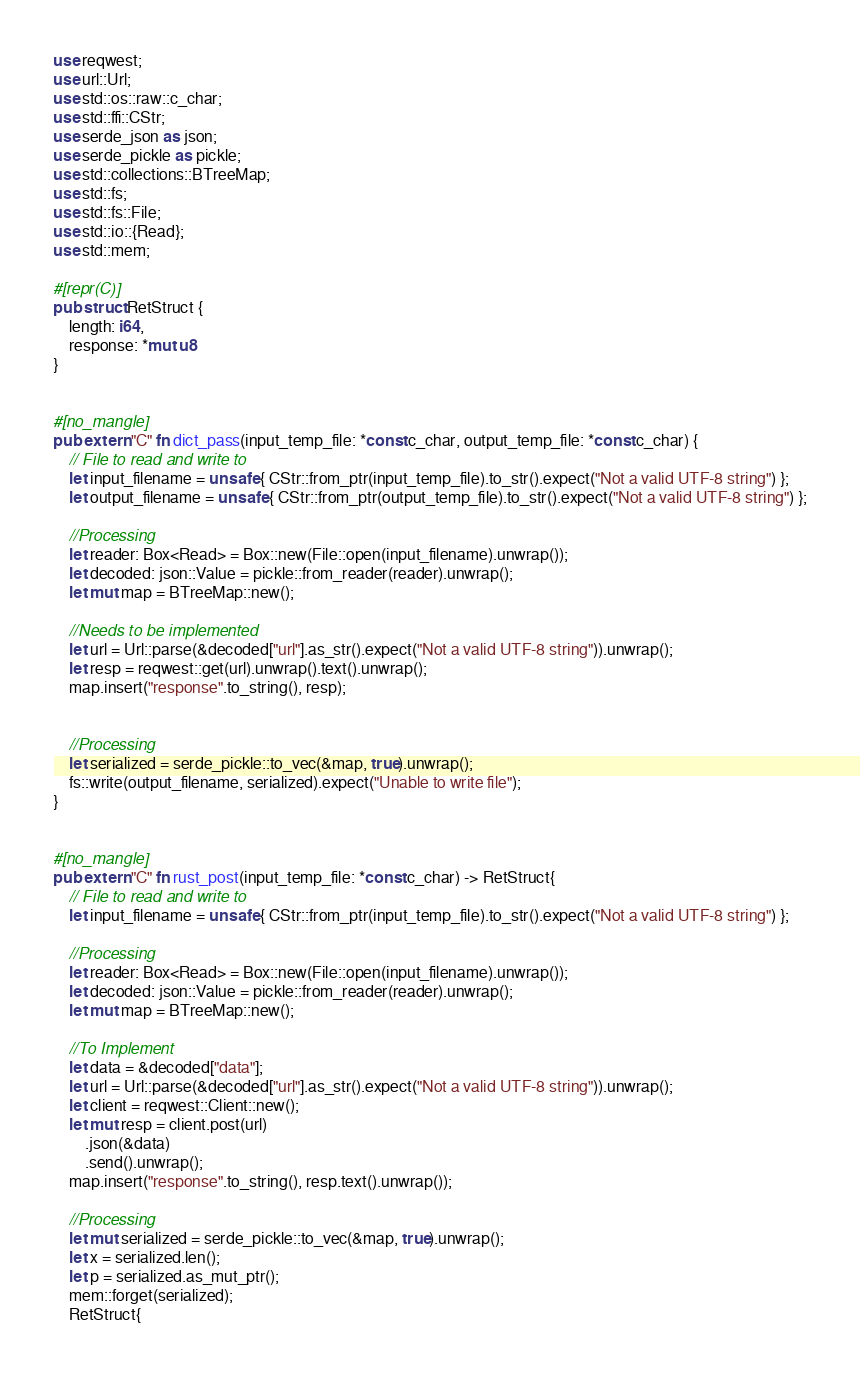Convert code to text. <code><loc_0><loc_0><loc_500><loc_500><_Rust_>use reqwest;
use url::Url;
use std::os::raw::c_char;
use std::ffi::CStr;
use serde_json as json;
use serde_pickle as pickle;
use std::collections::BTreeMap;
use std::fs;
use std::fs::File;
use std::io::{Read};
use std::mem;

#[repr(C)]
pub struct RetStruct {
    length: i64,
    response: *mut u8
}


#[no_mangle]
pub extern "C" fn dict_pass(input_temp_file: *const c_char, output_temp_file: *const c_char) {
    // File to read and write to
    let input_filename = unsafe { CStr::from_ptr(input_temp_file).to_str().expect("Not a valid UTF-8 string") };
    let output_filename = unsafe { CStr::from_ptr(output_temp_file).to_str().expect("Not a valid UTF-8 string") };

    //Processing
    let reader: Box<Read> = Box::new(File::open(input_filename).unwrap());
    let decoded: json::Value = pickle::from_reader(reader).unwrap();
    let mut map = BTreeMap::new();

    //Needs to be implemented
    let url = Url::parse(&decoded["url"].as_str().expect("Not a valid UTF-8 string")).unwrap();
    let resp = reqwest::get(url).unwrap().text().unwrap();
    map.insert("response".to_string(), resp);


    //Processing
    let serialized = serde_pickle::to_vec(&map, true).unwrap();
    fs::write(output_filename, serialized).expect("Unable to write file");
}


#[no_mangle]
pub extern "C" fn rust_post(input_temp_file: *const c_char) -> RetStruct{
    // File to read and write to
    let input_filename = unsafe { CStr::from_ptr(input_temp_file).to_str().expect("Not a valid UTF-8 string") };

    //Processing
    let reader: Box<Read> = Box::new(File::open(input_filename).unwrap());
    let decoded: json::Value = pickle::from_reader(reader).unwrap();
    let mut map = BTreeMap::new();

    //To Implement
    let data = &decoded["data"];
    let url = Url::parse(&decoded["url"].as_str().expect("Not a valid UTF-8 string")).unwrap();
    let client = reqwest::Client::new();
    let mut resp = client.post(url)
        .json(&data)
        .send().unwrap();
    map.insert("response".to_string(), resp.text().unwrap());

    //Processing
    let mut serialized = serde_pickle::to_vec(&map, true).unwrap();
    let x = serialized.len();
    let p = serialized.as_mut_ptr();
    mem::forget(serialized);
    RetStruct{</code> 